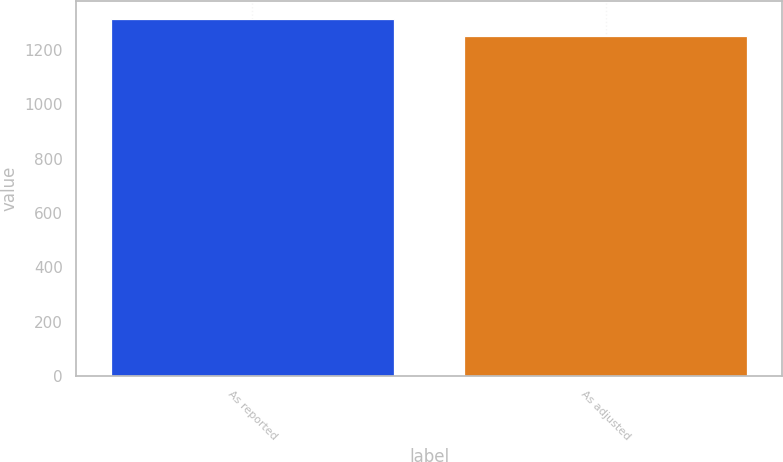Convert chart. <chart><loc_0><loc_0><loc_500><loc_500><bar_chart><fcel>As reported<fcel>As adjusted<nl><fcel>1314.7<fcel>1253.7<nl></chart> 